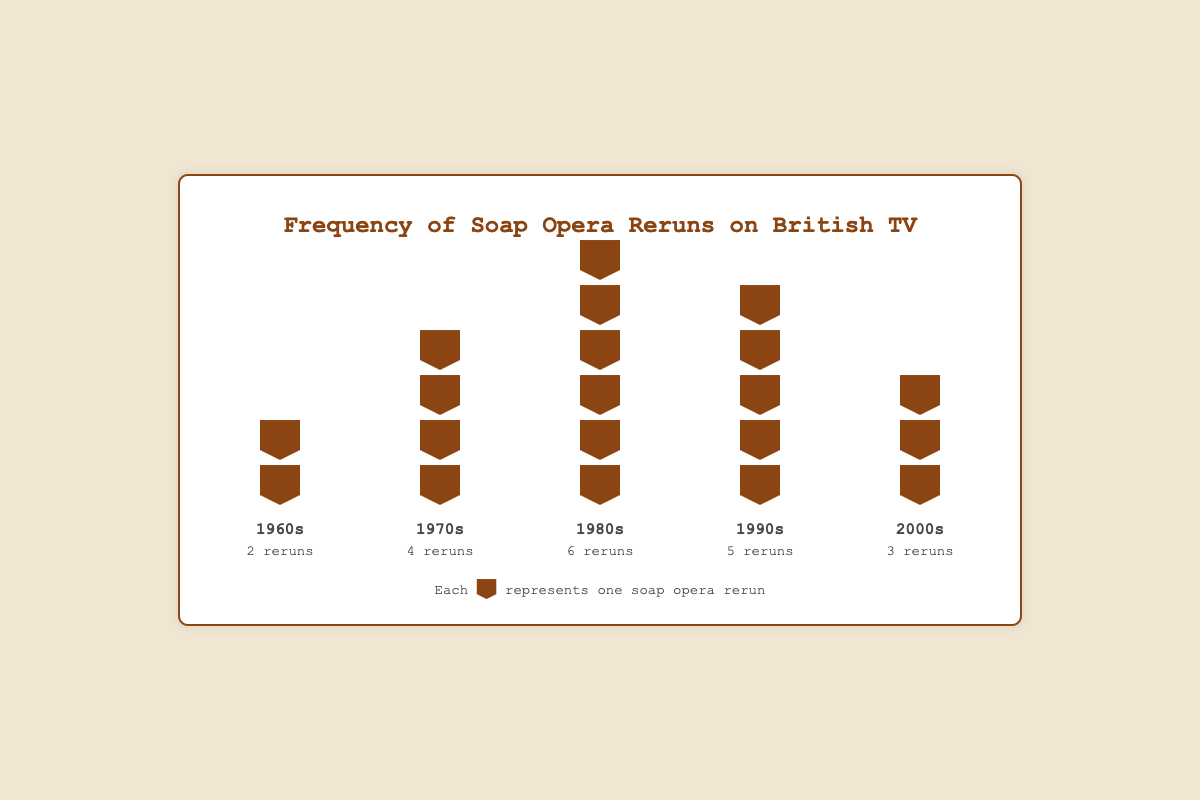Which decade has the highest number of soap opera reruns? Count the number of TV icons (each representing a rerun) for each decade and determine which has the most. The 1980s have the highest with 6 reruns.
Answer: 1980s How many soap opera reruns are there in total for the 1960s and 1970s combined? Add the reruns from the 1960s (2 reruns) and the 1970s (4 reruns). 2 + 4 = 6.
Answer: 6 Are there more soap opera reruns in the 1990s or the 2000s? Count the TV icons for both the 1990s (5 reruns) and the 2000s (3 reruns). The 1990s have more reruns.
Answer: 1990s Which two decades have a total of 8 reruns when combined? Calculate the sum of reruns for all combinations of decades. The combination of 1970s (4 reruns) and 2000s (3 reruns) does not work. The combination of the 1960s (2 reruns) and the 1980s (6 reruns) totals 8.
Answer: 1960s and 1980s What is the average number of soap opera reruns per decade? Calculate the total number of reruns across all decades (2+4+6+5+3 = 20) and divide by the number of decades (5). 20/5 = 4.
Answer: 4 Compare the 1970s and 1990s: which has more soap operas being rerun? Count the TV icons for the 1970s (4 reruns) and the 1990s (5 reruns). The 1990s have more.
Answer: 1990s What percentage of the total reruns does the 1980s contribute? Calculate the total number of reruns (20), and divide the 1980s reruns (6) by this total, then multiply by 100 for the percentage. (6/20)*100 = 30%.
Answer: 30% Which decade is represented by the fewest number of TV icons? Identify the decade with the least number of reruns by counting the TV icons per decade. The 1960s have the fewest with 2 reruns.
Answer: 1960s If you were to randomly pick a soap opera rerun, which decade would it most likely be from? The decade with the highest number of reruns will be the most likely, which is the 1980s with 6 reruns.
Answer: 1980s 